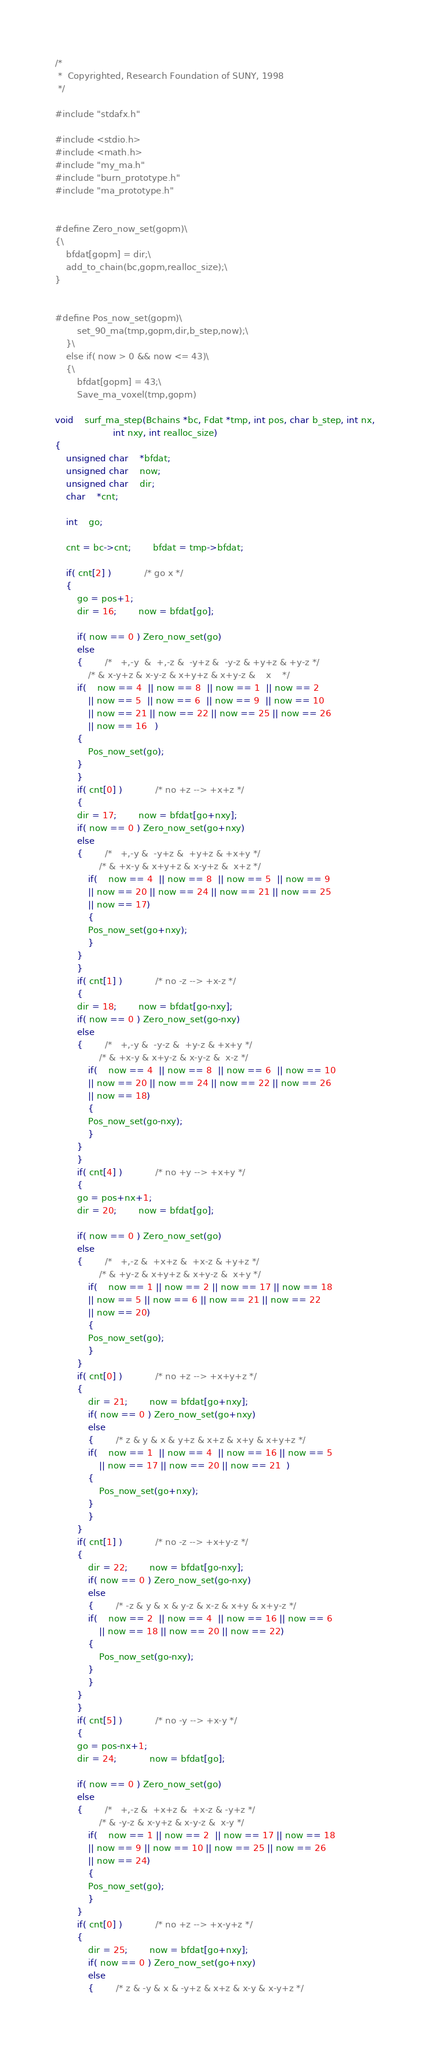Convert code to text. <code><loc_0><loc_0><loc_500><loc_500><_C_>/*
 *	Copyrighted, Research Foundation of SUNY, 1998
 */

#include "stdafx.h"

#include <stdio.h>
#include <math.h>
#include "my_ma.h"
#include "burn_prototype.h"
#include "ma_prototype.h"


#define Zero_now_set(gopm)\
{\
	bfdat[gopm] = dir;\
	add_to_chain(bc,gopm,realloc_size);\
}


#define Pos_now_set(gopm)\
		set_90_ma(tmp,gopm,dir,b_step,now);\
	}\
	else if( now > 0 && now <= 43)\
	{\
		bfdat[gopm] = 43;\
		Save_ma_voxel(tmp,gopm) 

void	surf_ma_step(Bchains *bc, Fdat *tmp, int pos, char b_step, int nx,
					 int nxy, int realloc_size)
{
	unsigned char	*bfdat;
	unsigned char	now;
	unsigned char	dir;
	char	*cnt;
	
	int	go;

	cnt = bc->cnt;		bfdat = tmp->bfdat;

	if( cnt[2] )			/* go x */
	{
	    go = pos+1;
	    dir = 16;		now = bfdat[go];

	    if( now == 0 ) Zero_now_set(go)
	    else
	    {		/*   +,-y  &  +,-z &  -y+z &  -y-z & +y+z & +y-z */
			/* & x-y+z & x-y-z & x+y+z & x+y-z &    x	 */
		if(    now == 4  || now == 8  || now == 1  || now == 2 
		    || now == 5  || now == 6  || now == 9  || now == 10
		    || now == 21 || now == 22 || now == 25 || now == 26
		    || now == 16   )
		{
		    Pos_now_set(go);
		}
	    }
	    if( cnt[0] )			/* no +z --> +x+z */
	    {
		dir = 17;		now = bfdat[go+nxy];
		if( now == 0 ) Zero_now_set(go+nxy)
		else
		{		/*   +,-y &  -y+z &  +y+z & +x+y */
				/* & +x-y & x+y+z & x-y+z &  x+z */
		    if(    now == 4  || now == 8  || now == 5  || now == 9
			|| now == 20 || now == 24 || now == 21 || now == 25
			|| now == 17)
		    {
			Pos_now_set(go+nxy);
		    }
		}
	    }
	    if( cnt[1] )			/* no -z --> +x-z */
	    {
		dir = 18;		now = bfdat[go-nxy];
		if( now == 0 ) Zero_now_set(go-nxy)
		else
		{		/*   +,-y &  -y-z &  +y-z & +x+y */
				/* & +x-y & x+y-z & x-y-z &  x-z */
		    if(    now == 4  || now == 8  || now == 6  || now == 10
			|| now == 20 || now == 24 || now == 22 || now == 26
			|| now == 18)
		    {
			Pos_now_set(go-nxy);
		    }
		}
	    }
	    if( cnt[4] )			/* no +y --> +x+y */
	    {
		go = pos+nx+1;
		dir = 20;		now = bfdat[go];

		if( now == 0 ) Zero_now_set(go)
		else
		{		/*   +,-z &  +x+z &  +x-z & +y+z */
				/* & +y-z & x+y+z & x+y-z &  x+y */
		    if(    now == 1 || now == 2 || now == 17 || now == 18
			|| now == 5 || now == 6 || now == 21 || now == 22
			|| now == 20)
		    {
			Pos_now_set(go);
		    }
		}
		if( cnt[0] )			/* no +z --> +x+y+z */
		{
		    dir = 21;		now = bfdat[go+nxy];
		    if( now == 0 ) Zero_now_set(go+nxy)
		    else 
		    {		/* z & y & x & y+z & x+z & x+y & x+y+z */
			if(    now == 1  || now == 4  || now == 16 || now == 5
			    || now == 17 || now == 20 || now == 21  )
			{
			    Pos_now_set(go+nxy);
			}
		    }
		}
		if( cnt[1] )			/* no -z --> +x+y-z */
		{
		    dir = 22;		now = bfdat[go-nxy];
		    if( now == 0 ) Zero_now_set(go-nxy)
		    else
		    {		/* -z & y & x & y-z & x-z & x+y & x+y-z */
			if(    now == 2  || now == 4  || now == 16 || now == 6
			    || now == 18 || now == 20 || now == 22)
			{
			    Pos_now_set(go-nxy);
			}
		    }
		}
	    }
	    if( cnt[5] )			/* no -y --> +x-y */
	    {
		go = pos-nx+1;
		dir = 24;			now = bfdat[go];

		if( now == 0 ) Zero_now_set(go)
		else
		{		/*   +,-z &  +x+z &  +x-z & -y+z */
				/* & -y-z & x-y+z & x-y-z &  x-y */
		    if(    now == 1 || now == 2  || now == 17 || now == 18
			|| now == 9 || now == 10 || now == 25 || now == 26
			|| now == 24)
		    {
			Pos_now_set(go);
		    }
		}
		if( cnt[0] )			/* no +z --> +x-y+z */
		{
		    dir = 25;		now = bfdat[go+nxy];
		    if( now == 0 ) Zero_now_set(go+nxy)
		    else 
		    {		/* z & -y & x & -y+z & x+z & x-y & x-y+z */</code> 